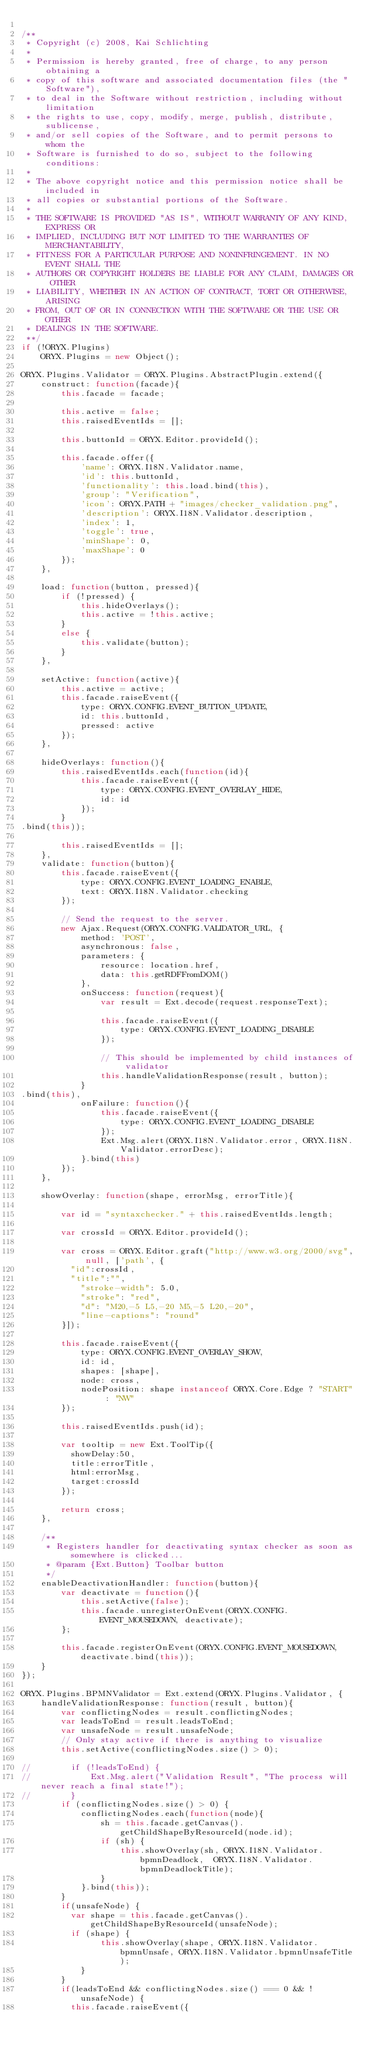Convert code to text. <code><loc_0><loc_0><loc_500><loc_500><_JavaScript_>
/**
 * Copyright (c) 2008, Kai Schlichting
 *
 * Permission is hereby granted, free of charge, to any person obtaining a
 * copy of this software and associated documentation files (the "Software"),
 * to deal in the Software without restriction, including without limitation
 * the rights to use, copy, modify, merge, publish, distribute, sublicense,
 * and/or sell copies of the Software, and to permit persons to whom the
 * Software is furnished to do so, subject to the following conditions:
 *
 * The above copyright notice and this permission notice shall be included in
 * all copies or substantial portions of the Software.
 *
 * THE SOFTWARE IS PROVIDED "AS IS", WITHOUT WARRANTY OF ANY KIND, EXPRESS OR
 * IMPLIED, INCLUDING BUT NOT LIMITED TO THE WARRANTIES OF MERCHANTABILITY,
 * FITNESS FOR A PARTICULAR PURPOSE AND NONINFRINGEMENT. IN NO EVENT SHALL THE
 * AUTHORS OR COPYRIGHT HOLDERS BE LIABLE FOR ANY CLAIM, DAMAGES OR OTHER
 * LIABILITY, WHETHER IN AN ACTION OF CONTRACT, TORT OR OTHERWISE, ARISING
 * FROM, OUT OF OR IN CONNECTION WITH THE SOFTWARE OR THE USE OR OTHER
 * DEALINGS IN THE SOFTWARE.
 **/
if (!ORYX.Plugins) 
    ORYX.Plugins = new Object();

ORYX.Plugins.Validator = ORYX.Plugins.AbstractPlugin.extend({
    construct: function(facade){
        this.facade = facade;
        
        this.active = false;
        this.raisedEventIds = [];
        
        this.buttonId = ORYX.Editor.provideId();
        
        this.facade.offer({
            'name': ORYX.I18N.Validator.name,
            'id': this.buttonId,
            'functionality': this.load.bind(this),
            'group': "Verification",
            'icon': ORYX.PATH + "images/checker_validation.png",
            'description': ORYX.I18N.Validator.description,
            'index': 1,
            'toggle': true,
            'minShape': 0,
            'maxShape': 0
        });
    },
    
    load: function(button, pressed){
        if (!pressed) {
            this.hideOverlays();
            this.active = !this.active;
        }
        else {
            this.validate(button);
        }
    },
    
    setActive: function(active){
        this.active = active;
        this.facade.raiseEvent({
            type: ORYX.CONFIG.EVENT_BUTTON_UPDATE,
            id: this.buttonId,
            pressed: active
        });
    },
    
    hideOverlays: function(){
        this.raisedEventIds.each(function(id){
            this.facade.raiseEvent({
                type: ORYX.CONFIG.EVENT_OVERLAY_HIDE,
                id: id
            });
        }
.bind(this));
        
        this.raisedEventIds = [];
    },
    validate: function(button){
        this.facade.raiseEvent({
            type: ORYX.CONFIG.EVENT_LOADING_ENABLE,
            text: ORYX.I18N.Validator.checking
        });
      
        // Send the request to the server.
        new Ajax.Request(ORYX.CONFIG.VALIDATOR_URL, {
            method: 'POST',
            asynchronous: false,
            parameters: {
                resource: location.href,
                data: this.getRDFFromDOM()
            },
            onSuccess: function(request){
                var result = Ext.decode(request.responseText);
                
                this.facade.raiseEvent({
                    type: ORYX.CONFIG.EVENT_LOADING_DISABLE
                });
                
                // This should be implemented by child instances of validator 
                this.handleValidationResponse(result, button);
            }
.bind(this),
            onFailure: function(){
                this.facade.raiseEvent({
                    type: ORYX.CONFIG.EVENT_LOADING_DISABLE
                });
                Ext.Msg.alert(ORYX.I18N.Validator.error, ORYX.I18N.Validator.errorDesc);
            }.bind(this)
        });
    },
    
    showOverlay: function(shape, errorMsg, errorTitle){
    
        var id = "syntaxchecker." + this.raisedEventIds.length;
        
        var crossId = ORYX.Editor.provideId();
        
        var cross = ORYX.Editor.graft("http://www.w3.org/2000/svg", null, ['path', {
        	"id":crossId,
        	"title":"",
            "stroke-width": 5.0,
            "stroke": "red",
            "d": "M20,-5 L5,-20 M5,-5 L20,-20",
            "line-captions": "round"
        }]);
        
        this.facade.raiseEvent({
            type: ORYX.CONFIG.EVENT_OVERLAY_SHOW,
            id: id,
            shapes: [shape],
            node: cross,
            nodePosition: shape instanceof ORYX.Core.Edge ? "START" : "NW"
        });
        
        this.raisedEventIds.push(id);
        
        var tooltip = new Ext.ToolTip({
        	showDelay:50,
        	title:errorTitle,
        	html:errorMsg,
        	target:crossId
        });   
        
        return cross;
    },
    
    /**
     * Registers handler for deactivating syntax checker as soon as somewhere is clicked...
     * @param {Ext.Button} Toolbar button
     */
    enableDeactivationHandler: function(button){
        var deactivate = function(){
            this.setActive(false);
            this.facade.unregisterOnEvent(ORYX.CONFIG.EVENT_MOUSEDOWN, deactivate);
        };
        
        this.facade.registerOnEvent(ORYX.CONFIG.EVENT_MOUSEDOWN, deactivate.bind(this));
    }
});

ORYX.Plugins.BPMNValidator = Ext.extend(ORYX.Plugins.Validator, {
    handleValidationResponse: function(result, button){
        var conflictingNodes = result.conflictingNodes;
        var leadsToEnd = result.leadsToEnd;
        var unsafeNode = result.unsafeNode;
        // Only stay active if there is anything to visualize
        this.setActive(conflictingNodes.size() > 0);
        
//        if (!leadsToEnd) {
//            Ext.Msg.alert("Validation Result", "The process will never reach a final state!");
//        }
        if (conflictingNodes.size() > 0) {
            conflictingNodes.each(function(node){
                sh = this.facade.getCanvas().getChildShapeByResourceId(node.id);
                if (sh) {
                    this.showOverlay(sh, ORYX.I18N.Validator.bpmnDeadlock,  ORYX.I18N.Validator.bpmnDeadlockTitle);
                }
            }.bind(this));
        }
        if(unsafeNode) {
        	var shape = this.facade.getCanvas().getChildShapeByResourceId(unsafeNode);
        	if (shape) {
                this.showOverlay(shape, ORYX.I18N.Validator.bpmnUnsafe, ORYX.I18N.Validator.bpmnUnsafeTitle);
            }
        }
        if(leadsToEnd && conflictingNodes.size() === 0 && !unsafeNode) {
        	this.facade.raiseEvent({</code> 